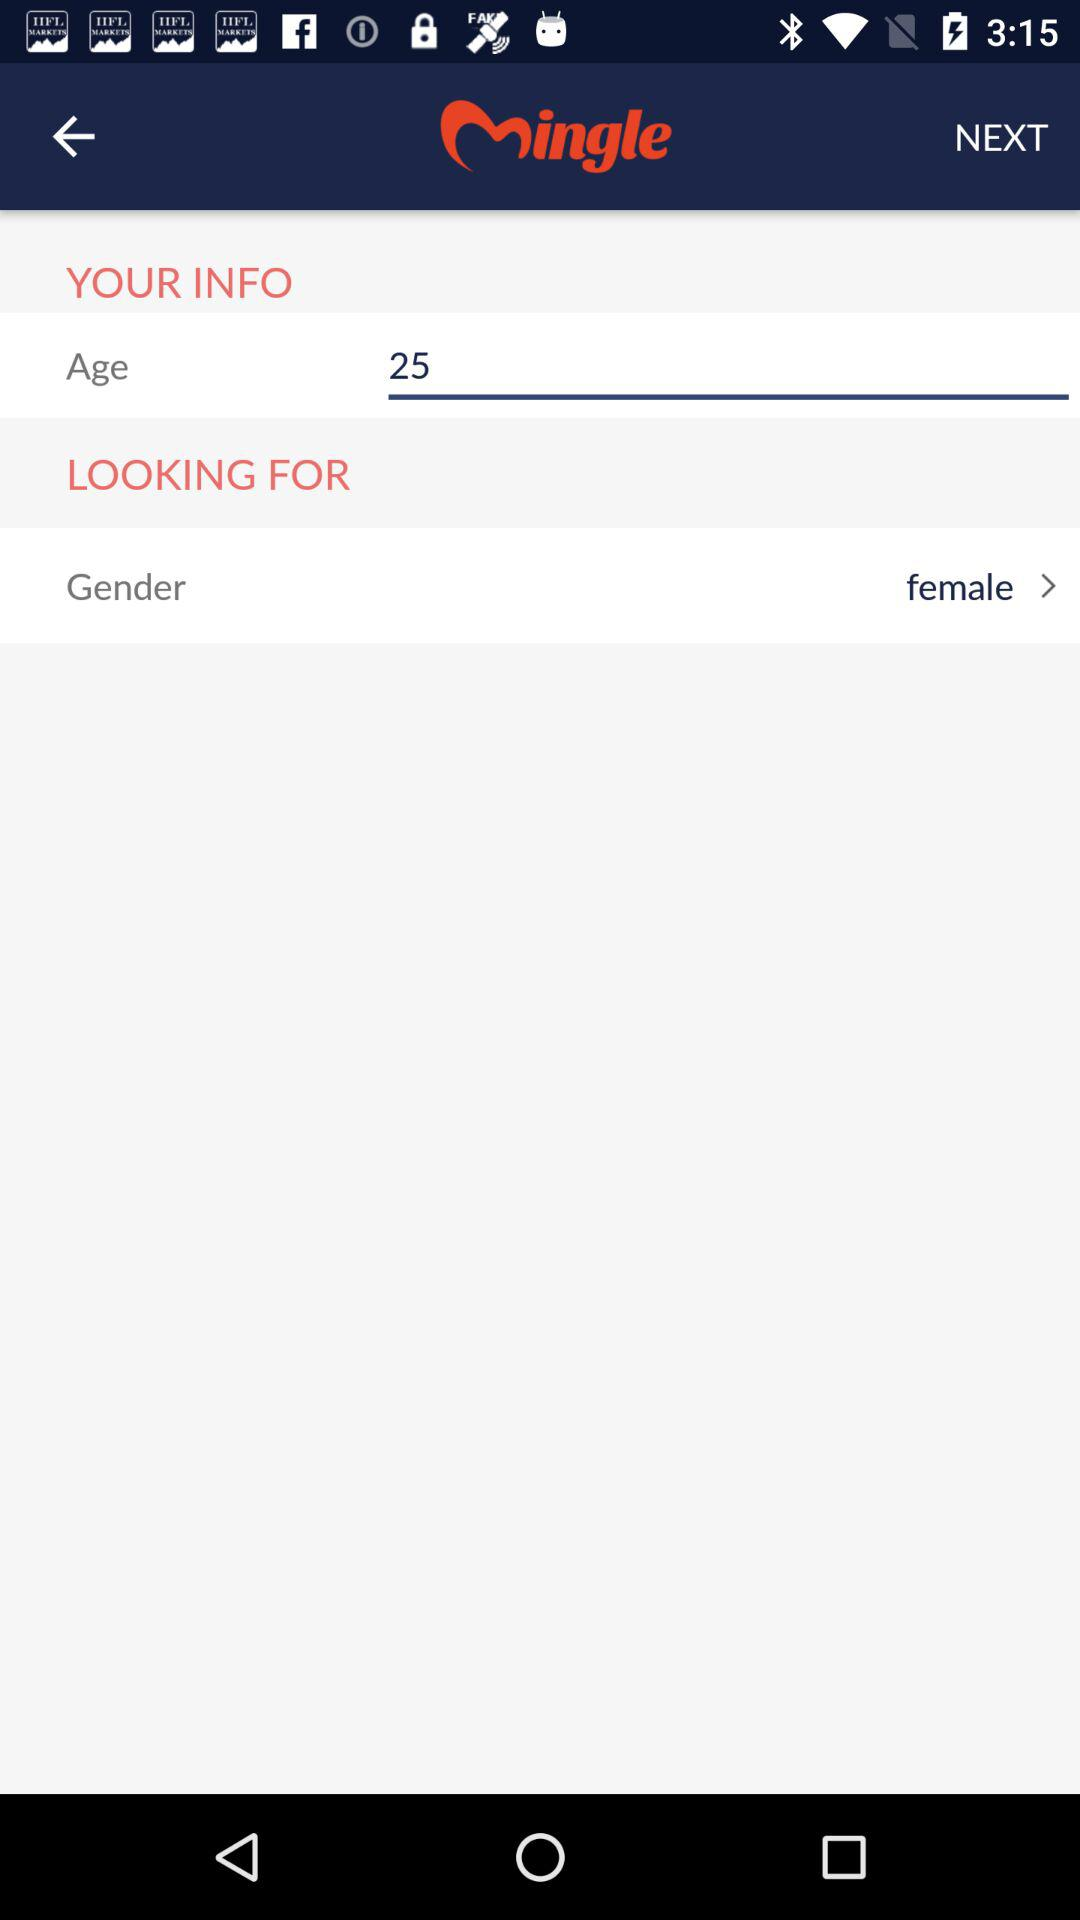What is the age? The age is 25 years. 